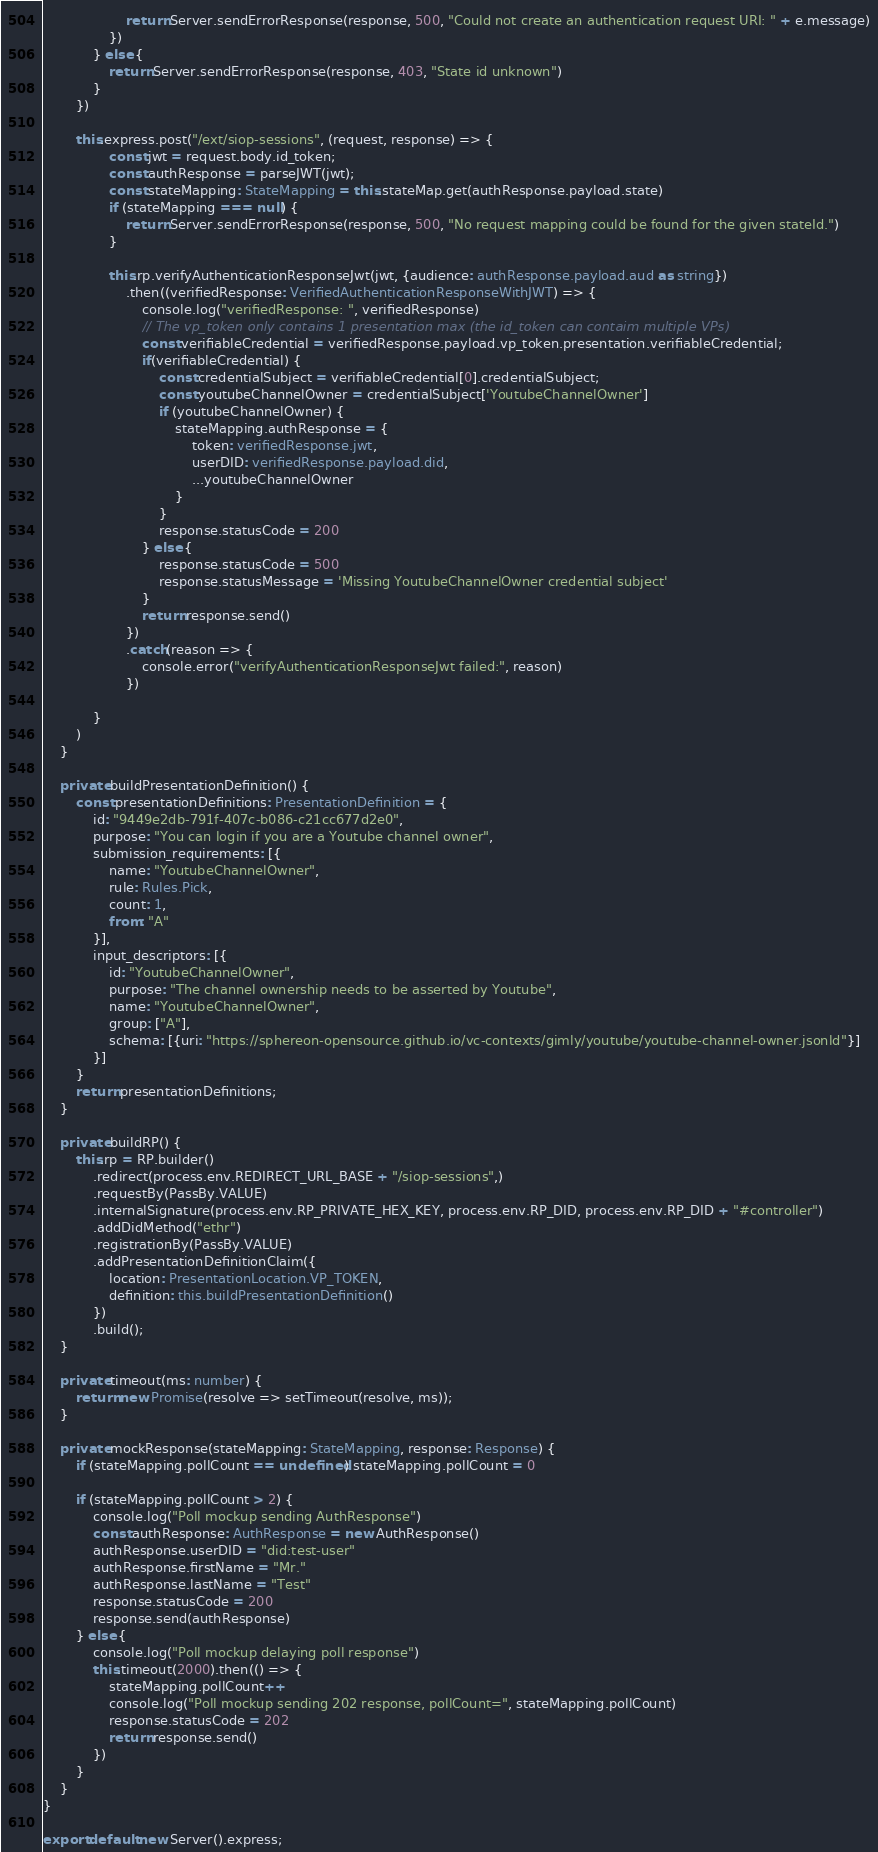<code> <loc_0><loc_0><loc_500><loc_500><_TypeScript_>                    return Server.sendErrorResponse(response, 500, "Could not create an authentication request URI: " + e.message)
                })
            } else {
                return Server.sendErrorResponse(response, 403, "State id unknown")
            }
        })

        this.express.post("/ext/siop-sessions", (request, response) => {
                const jwt = request.body.id_token;
                const authResponse = parseJWT(jwt);
                const stateMapping: StateMapping = this.stateMap.get(authResponse.payload.state)
                if (stateMapping === null) {
                    return Server.sendErrorResponse(response, 500, "No request mapping could be found for the given stateId.")
                }

                this.rp.verifyAuthenticationResponseJwt(jwt, {audience: authResponse.payload.aud as string})
                    .then((verifiedResponse: VerifiedAuthenticationResponseWithJWT) => {
                        console.log("verifiedResponse: ", verifiedResponse)
                        // The vp_token only contains 1 presentation max (the id_token can contaim multiple VPs)
                        const verifiableCredential = verifiedResponse.payload.vp_token.presentation.verifiableCredential;
                        if(verifiableCredential) {
                            const credentialSubject = verifiableCredential[0].credentialSubject;
                            const youtubeChannelOwner = credentialSubject['YoutubeChannelOwner']
                            if (youtubeChannelOwner) {
                                stateMapping.authResponse = {
                                    token: verifiedResponse.jwt,
                                    userDID: verifiedResponse.payload.did,
                                    ...youtubeChannelOwner
                                }
                            }
                            response.statusCode = 200
                        } else {
                            response.statusCode = 500
                            response.statusMessage = 'Missing YoutubeChannelOwner credential subject'
                        }
                        return response.send()
                    })
                    .catch(reason => {
                        console.error("verifyAuthenticationResponseJwt failed:", reason)
                    })

            }
        )
    }

    private buildPresentationDefinition() {
        const presentationDefinitions: PresentationDefinition = {
            id: "9449e2db-791f-407c-b086-c21cc677d2e0",
            purpose: "You can login if you are a Youtube channel owner",
            submission_requirements: [{
                name: "YoutubeChannelOwner",
                rule: Rules.Pick,
                count: 1,
                from: "A"
            }],
            input_descriptors: [{
                id: "YoutubeChannelOwner",
                purpose: "The channel ownership needs to be asserted by Youtube",
                name: "YoutubeChannelOwner",
                group: ["A"],
                schema: [{uri: "https://sphereon-opensource.github.io/vc-contexts/gimly/youtube/youtube-channel-owner.jsonld"}]
            }]
        }
        return presentationDefinitions;
    }

    private buildRP() {
        this.rp = RP.builder()
            .redirect(process.env.REDIRECT_URL_BASE + "/siop-sessions",)
            .requestBy(PassBy.VALUE)
            .internalSignature(process.env.RP_PRIVATE_HEX_KEY, process.env.RP_DID, process.env.RP_DID + "#controller")
            .addDidMethod("ethr")
            .registrationBy(PassBy.VALUE)
            .addPresentationDefinitionClaim({
                location: PresentationLocation.VP_TOKEN,
                definition: this.buildPresentationDefinition()
            })
            .build();
    }

    private timeout(ms: number) {
        return new Promise(resolve => setTimeout(resolve, ms));
    }

    private mockResponse(stateMapping: StateMapping, response: Response) {
        if (stateMapping.pollCount == undefined) stateMapping.pollCount = 0

        if (stateMapping.pollCount > 2) {
            console.log("Poll mockup sending AuthResponse")
            const authResponse: AuthResponse = new AuthResponse()
            authResponse.userDID = "did:test-user"
            authResponse.firstName = "Mr."
            authResponse.lastName = "Test"
            response.statusCode = 200
            response.send(authResponse)
        } else {
            console.log("Poll mockup delaying poll response")
            this.timeout(2000).then(() => {
                stateMapping.pollCount++
                console.log("Poll mockup sending 202 response, pollCount=", stateMapping.pollCount)
                response.statusCode = 202
                return response.send()
            })
        }
    }
}

export default new Server().express;
</code> 